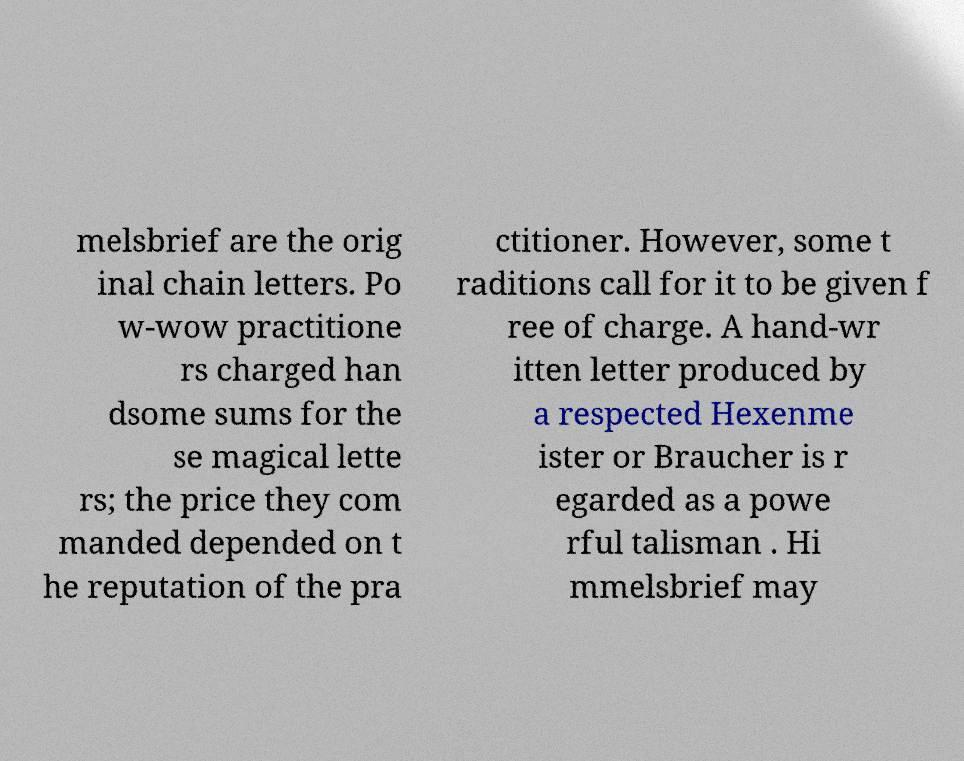Can you accurately transcribe the text from the provided image for me? melsbrief are the orig inal chain letters. Po w-wow practitione rs charged han dsome sums for the se magical lette rs; the price they com manded depended on t he reputation of the pra ctitioner. However, some t raditions call for it to be given f ree of charge. A hand-wr itten letter produced by a respected Hexenme ister or Braucher is r egarded as a powe rful talisman . Hi mmelsbrief may 